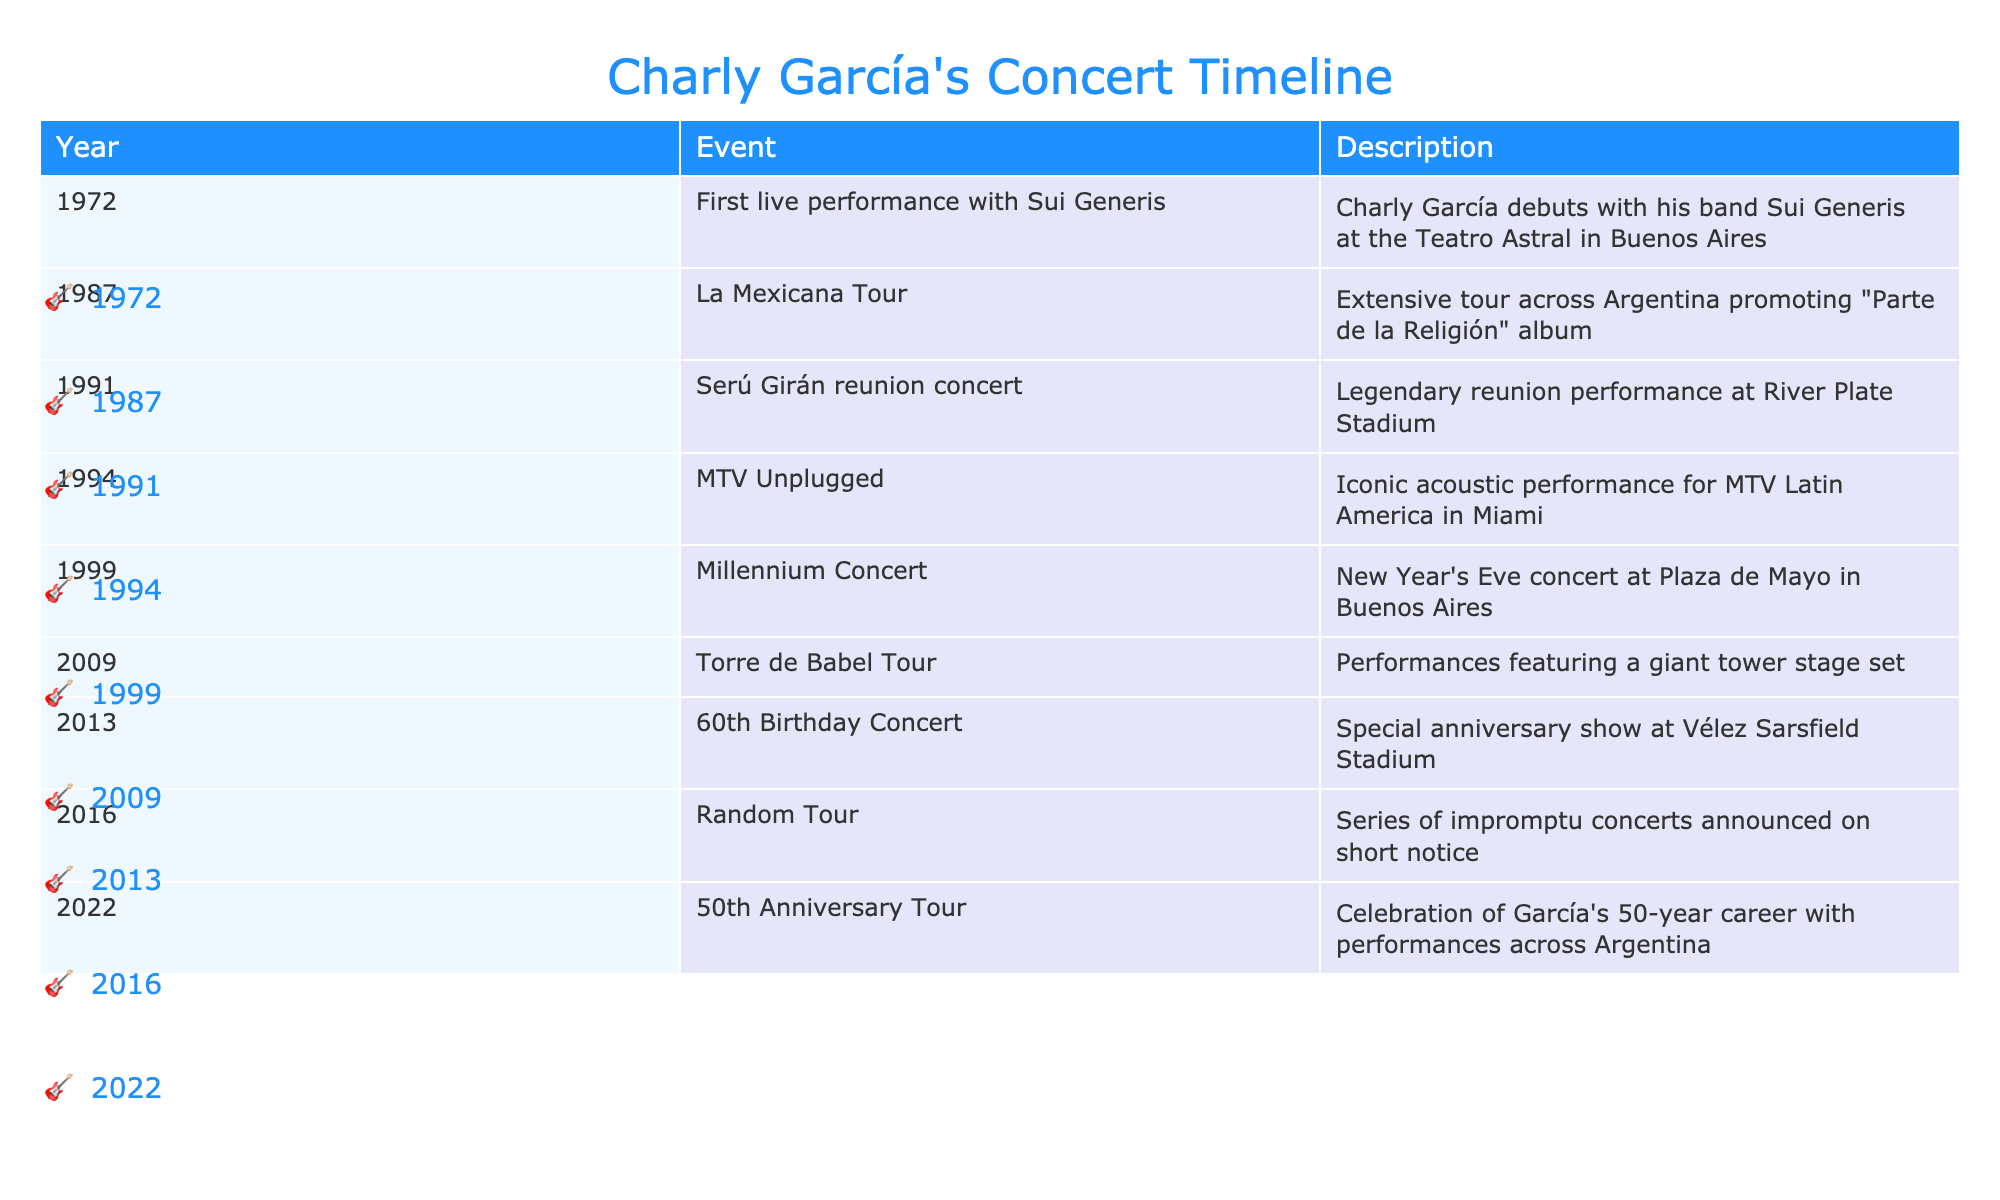What year did Charly García debut with Sui Generis? The table shows that Charly García's first live performance with Sui Generis occurred in 1972.
Answer: 1972 Which event took place in 1987? The event listed for 1987 is the La Mexicana Tour, which involved an extensive concert tour across Argentina.
Answer: La Mexicana Tour Was there a concert celebrating Charly García's 60th birthday? The table confirms that there was a special anniversary show for Charly García's 60th birthday in 2013.
Answer: Yes How many years apart were the MTV Unplugged and the Millennium Concert? The MTV Unplugged performance took place in 1994 and the Millennium Concert in 1999; the difference between 1999 and 1994 is 5 years.
Answer: 5 years What is the significance of the 2022 tour mentioned in the table? The 2022 tour is significant as it celebrates Charly García's 50-year career with performances across Argentina, indicating a milestone in his career.
Answer: 50-year career celebration Which event occurred most recently in the timeline? The most recent event in the timeline is the 2022 50th Anniversary Tour, as it is the last entry in the table.
Answer: 50th Anniversary Tour How many notable performances are listed in the table before 2000? The table lists four notable performances before 2000: 1972, 1987, 1991, and 1994. Count them yields a total of four events.
Answer: 4 Is the Random Tour associated with a specific album? The table does not associate the Random Tour with a specific album; instead, it mentions it was a series of impromptu concerts announced on short notice.
Answer: No Which concert event had the largest attendance location mentioned? The Serú Girán reunion concert at River Plate Stadium is noted for its legendary performance, which suggests high attendance at a major venue.
Answer: River Plate Stadium 